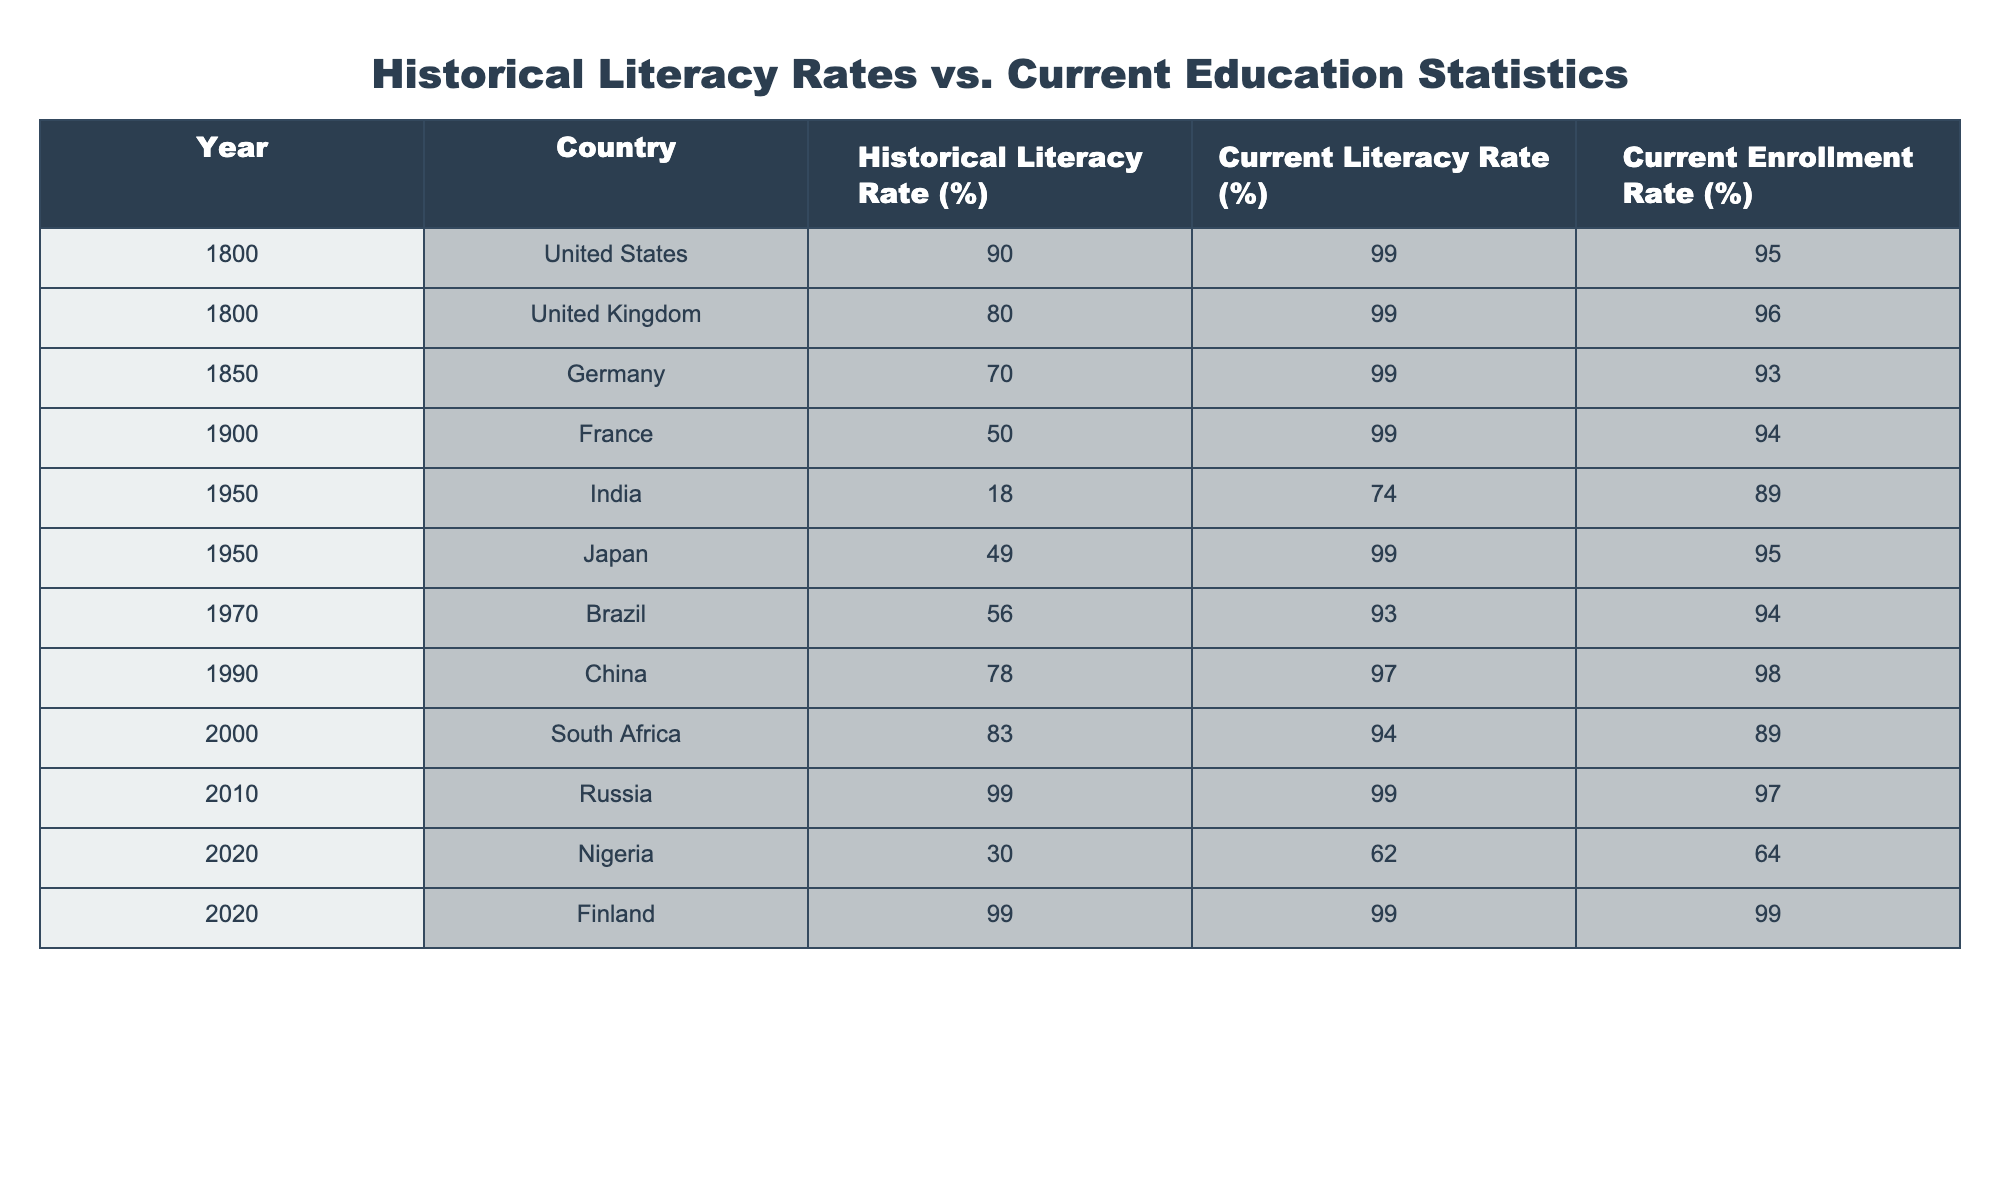What was the historical literacy rate in the United Kingdom in 1800? The table shows that the historical literacy rate for the United Kingdom in 1800 is listed as 80%.
Answer: 80% What is the current enrollment rate in China as of 1990? According to the table, the current enrollment rate in China for the year 1990 is 98%.
Answer: 98% By how much did India's literacy rate increase from 1950 to 2020? In 1950, India's literacy rate was 18%, and in 2020 it was 62%. The increase is calculated as 62% - 18% = 44%.
Answer: 44% Which country had the highest historical literacy rate among those listed in the table? The table indicates that Finland had a historical literacy rate of 99% in 2020, which is the highest among the listed countries.
Answer: Finland Which country experienced the largest difference between historical and current literacy rates? To determine this, we look for the maximum difference: India in 1950 had an increase from 18% to 74%, which is a 56% difference (74% - 18%). In comparison, other countries do not exceed this difference.
Answer: India Is the current literacy rate in Japan higher than its historical literacy rate in 1950? The current literacy rate in Japan is 99%, while its historical literacy rate in 1950 was 49%. Since 99% is greater than 49%, the statement is true.
Answer: Yes What is the average current enrollment rate across all listed countries in 2020? The current enrollment rates are 95%, 96%, 93%, 98%, 89%, 64%, 99%, and 99%. Summing these values gives 73.125%. There are 8 countries, so the average is 73.125% / 8 = 91.875%.
Answer: 91.875% In which year did Nigeria have the lowest literacy rate compared to other countries? By examining the table, Nigeria's literacy rate in 2020 is 62%, which is lower than all other listed countries' current literacy rates. Therefore, it represents the lowest literacy rate.
Answer: 2020 What percentage of current enrollment rates is greater than 90%? Among the listed current enrollment rates, the values greater than 90% are (95, 96, 93, 98, 94, 97, 99, 99) totaling 7 out of 8 countries. Thus, the percentage is (7/8) * 100 = 87.5%.
Answer: 87.5% 